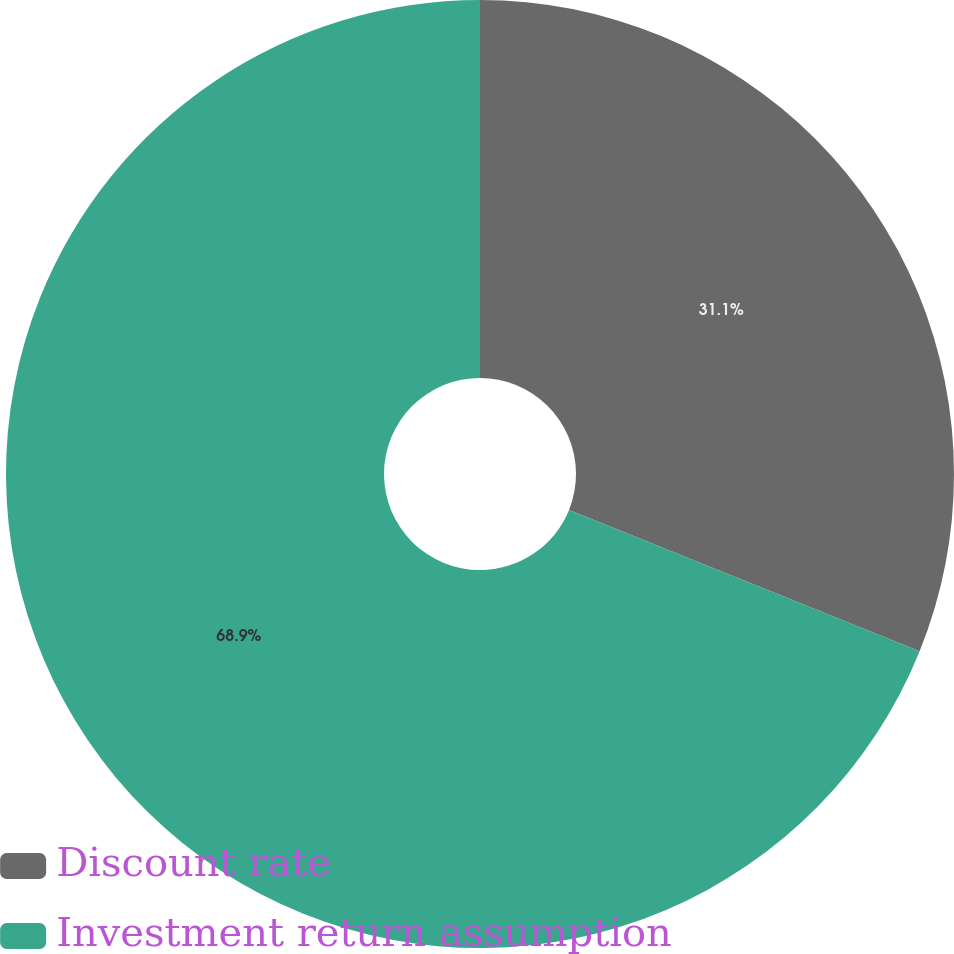<chart> <loc_0><loc_0><loc_500><loc_500><pie_chart><fcel>Discount rate<fcel>Investment return assumption<nl><fcel>31.1%<fcel>68.9%<nl></chart> 